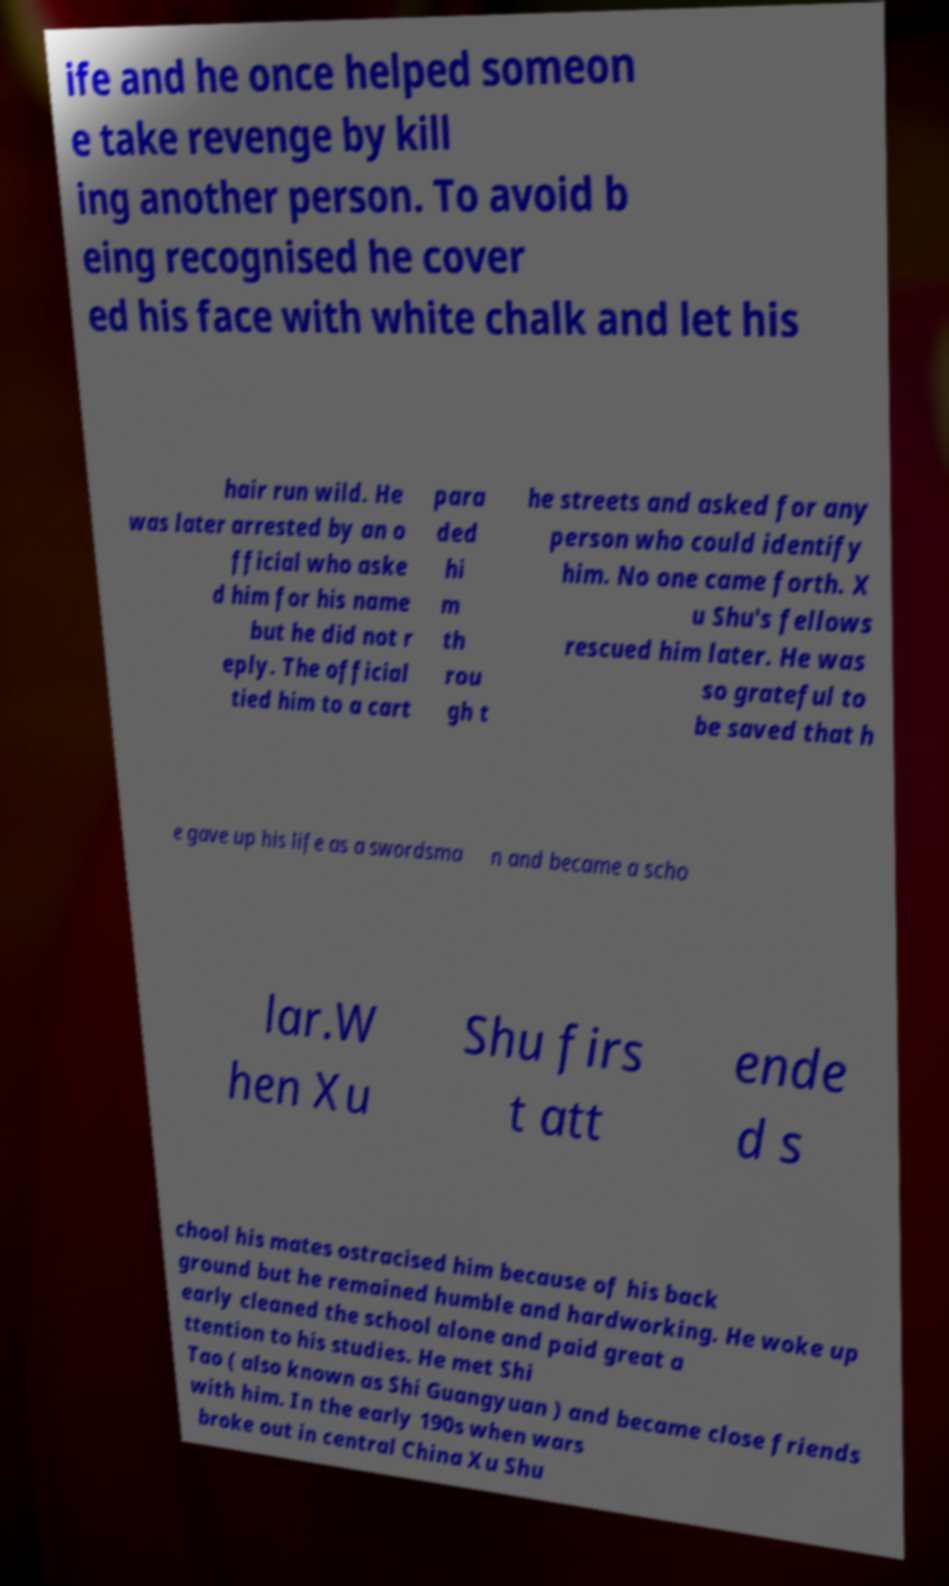There's text embedded in this image that I need extracted. Can you transcribe it verbatim? ife and he once helped someon e take revenge by kill ing another person. To avoid b eing recognised he cover ed his face with white chalk and let his hair run wild. He was later arrested by an o fficial who aske d him for his name but he did not r eply. The official tied him to a cart para ded hi m th rou gh t he streets and asked for any person who could identify him. No one came forth. X u Shu's fellows rescued him later. He was so grateful to be saved that h e gave up his life as a swordsma n and became a scho lar.W hen Xu Shu firs t att ende d s chool his mates ostracised him because of his back ground but he remained humble and hardworking. He woke up early cleaned the school alone and paid great a ttention to his studies. He met Shi Tao ( also known as Shi Guangyuan ) and became close friends with him. In the early 190s when wars broke out in central China Xu Shu 